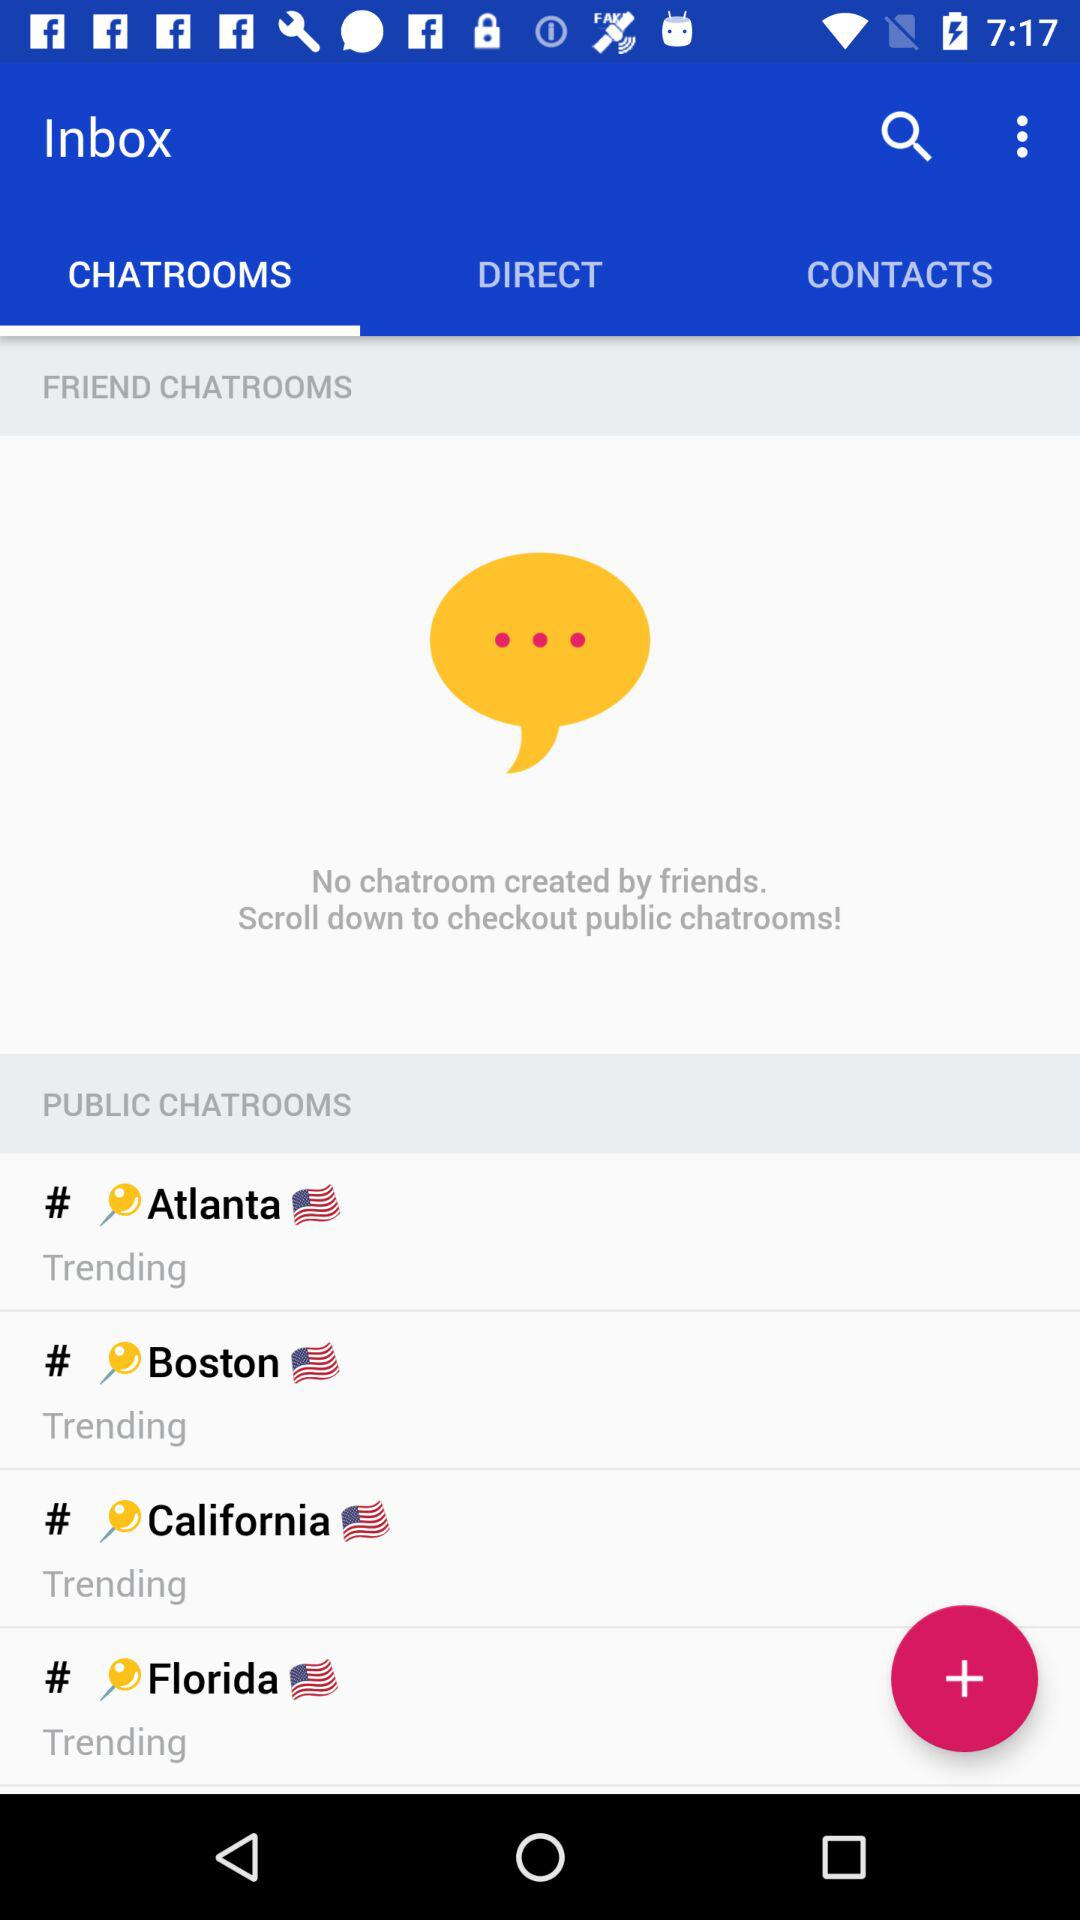How many public chatrooms are there?
Answer the question using a single word or phrase. 4 